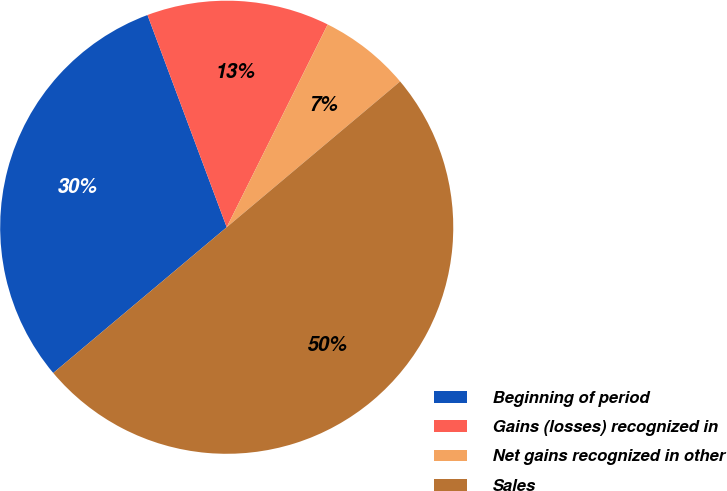Convert chart to OTSL. <chart><loc_0><loc_0><loc_500><loc_500><pie_chart><fcel>Beginning of period<fcel>Gains (losses) recognized in<fcel>Net gains recognized in other<fcel>Sales<nl><fcel>30.43%<fcel>13.04%<fcel>6.52%<fcel>50.0%<nl></chart> 